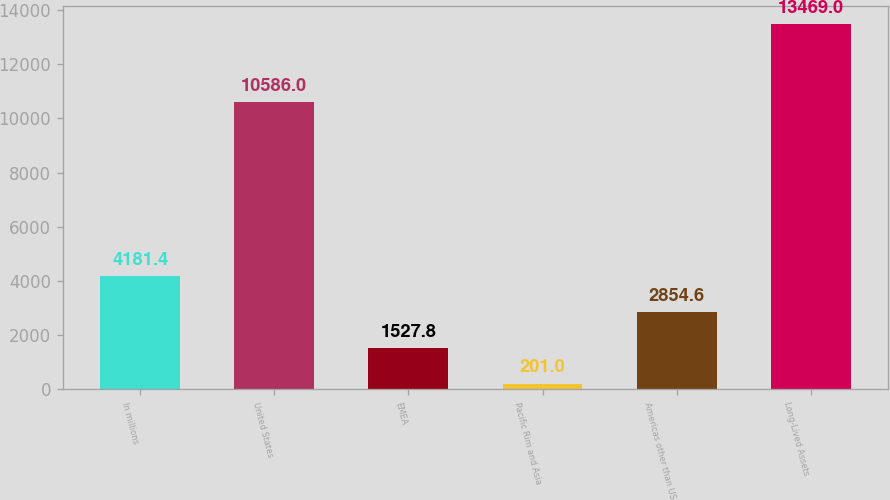Convert chart. <chart><loc_0><loc_0><loc_500><loc_500><bar_chart><fcel>In millions<fcel>United States<fcel>EMEA<fcel>Pacific Rim and Asia<fcel>Americas other than US<fcel>Long-Lived Assets<nl><fcel>4181.4<fcel>10586<fcel>1527.8<fcel>201<fcel>2854.6<fcel>13469<nl></chart> 